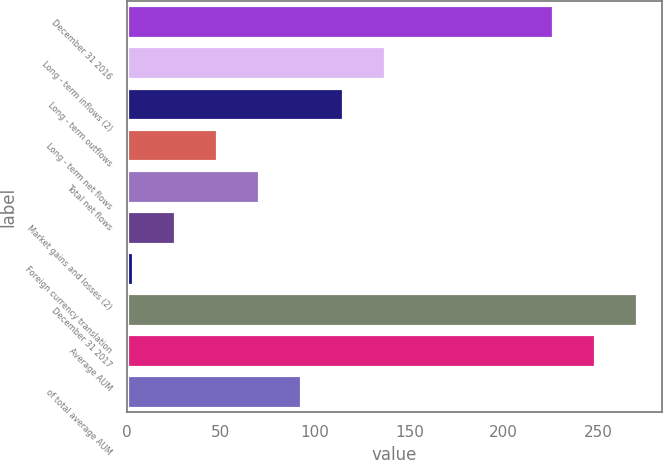Convert chart. <chart><loc_0><loc_0><loc_500><loc_500><bar_chart><fcel>December 31 2016<fcel>Long - term inflows (2)<fcel>Long - term outflows<fcel>Long - term net flows<fcel>Total net flows<fcel>Market gains and losses (2)<fcel>Foreign currency translation<fcel>December 31 2017<fcel>Average AUM<fcel>of total average AUM<nl><fcel>226.12<fcel>136.76<fcel>114.5<fcel>47.72<fcel>69.98<fcel>25.46<fcel>3.2<fcel>270.64<fcel>248.38<fcel>92.24<nl></chart> 